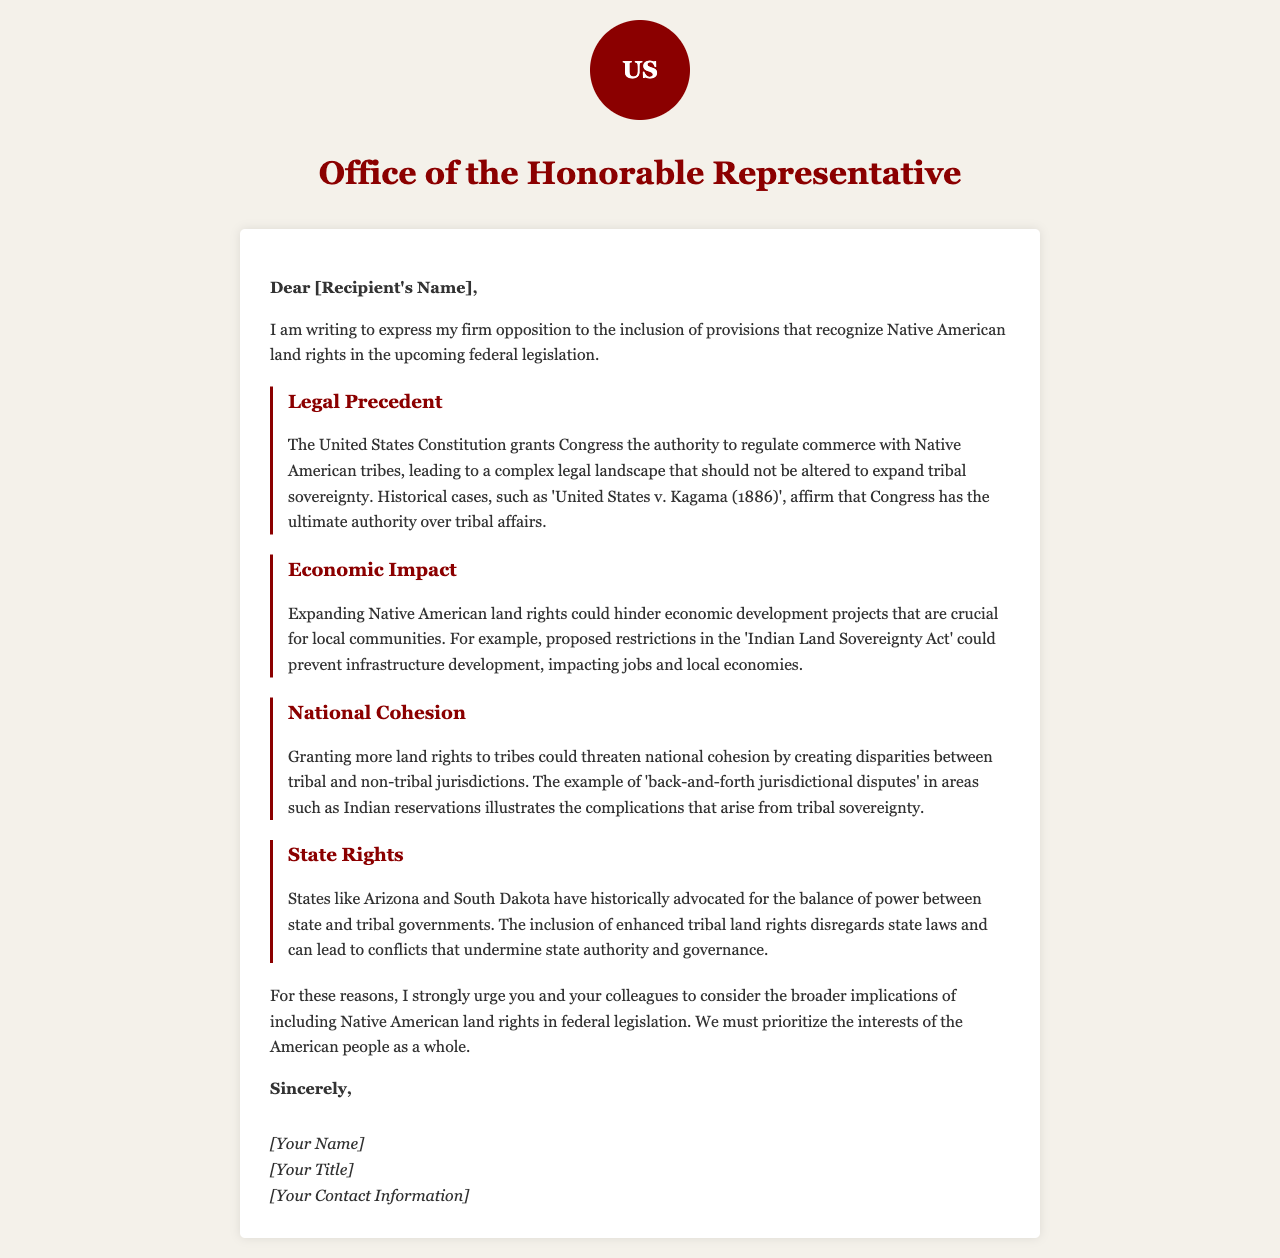What is the title of the letter? The title of the letter is mentioned in the HTML code as the page title.
Answer: Opposition to Native American Land Rights Legislation Who is the letter addressed to? The recipient's name is indicated in the greeting section, but it is a placeholder.
Answer: [Recipient's Name] What legal case is referenced in the letter? The letter cites a specific legal precedent relevant to the topic of tribal sovereignty.
Answer: United States v. Kagama (1886) What is the argument related to economic impact? The letter presents an argument that speaks to the consequences of recognizing land rights on local economies.
Answer: Economic development projects Which states are mentioned concerning state rights? The letter has specific states that are noted for their position on the balance of power with tribal governments.
Answer: Arizona and South Dakota What is the call to action in the letter? The conclusion urges a specific action regarding the upcoming federal legislation.
Answer: Consider broader implications What does the author urge the colleagues to prioritize? The author emphasizes the need to focus on a certain principle regarding legislation.
Answer: Interests of the American people as a whole What is the closing salutation of the letter? The letter concludes with a formal closing phrase before the signature.
Answer: Sincerely What is the design color used for headers throughout the document? The color specified in the CSS for header elements in the document is mentioned.
Answer: #8b0000 